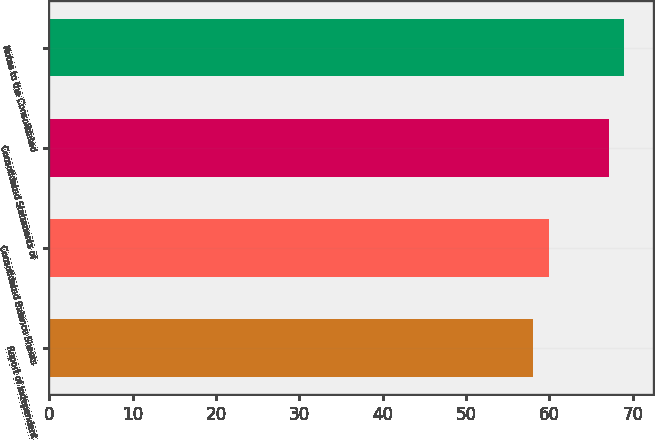Convert chart to OTSL. <chart><loc_0><loc_0><loc_500><loc_500><bar_chart><fcel>Report of Independent<fcel>Consolidated Balance Sheets<fcel>Consolidated Statements of<fcel>Notes to the Consolidated<nl><fcel>58<fcel>60<fcel>67.1<fcel>69<nl></chart> 